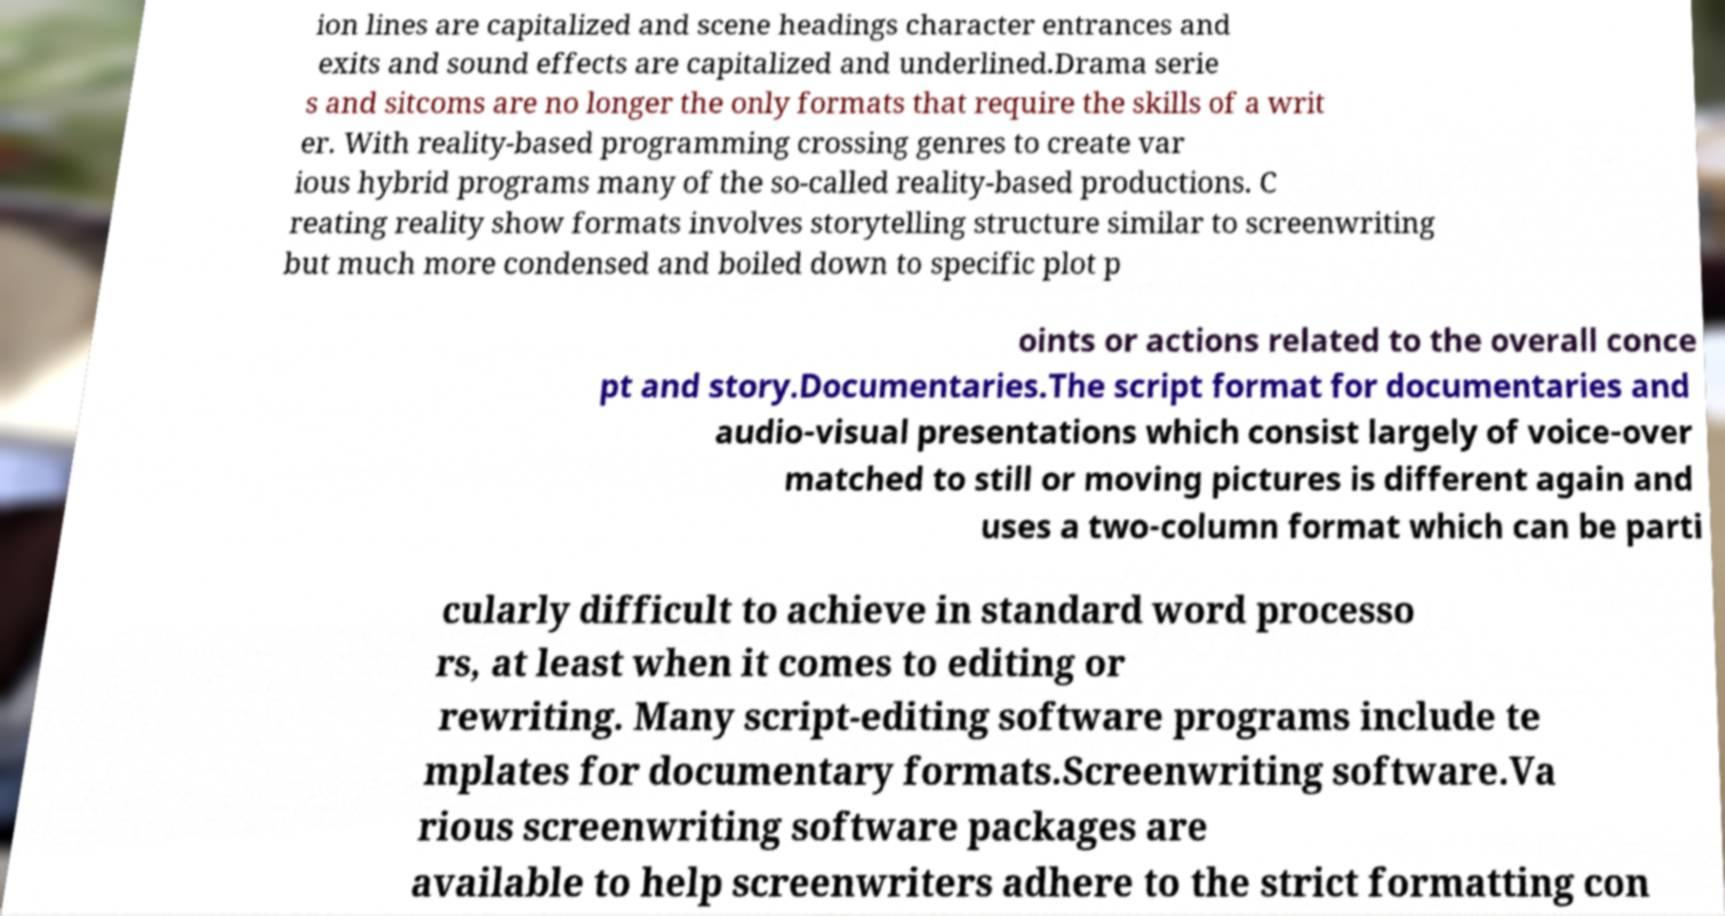Can you accurately transcribe the text from the provided image for me? ion lines are capitalized and scene headings character entrances and exits and sound effects are capitalized and underlined.Drama serie s and sitcoms are no longer the only formats that require the skills of a writ er. With reality-based programming crossing genres to create var ious hybrid programs many of the so-called reality-based productions. C reating reality show formats involves storytelling structure similar to screenwriting but much more condensed and boiled down to specific plot p oints or actions related to the overall conce pt and story.Documentaries.The script format for documentaries and audio-visual presentations which consist largely of voice-over matched to still or moving pictures is different again and uses a two-column format which can be parti cularly difficult to achieve in standard word processo rs, at least when it comes to editing or rewriting. Many script-editing software programs include te mplates for documentary formats.Screenwriting software.Va rious screenwriting software packages are available to help screenwriters adhere to the strict formatting con 